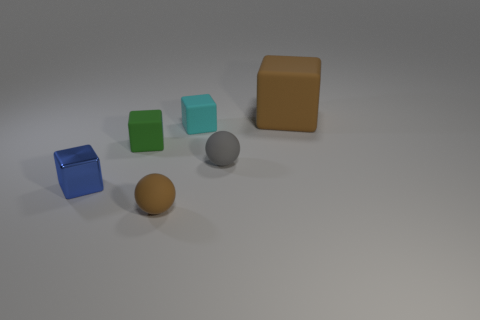Subtract all big brown rubber blocks. How many blocks are left? 3 Subtract 2 cubes. How many cubes are left? 2 Add 3 brown rubber balls. How many objects exist? 9 Subtract all brown balls. How many balls are left? 1 Subtract all cubes. How many objects are left? 2 Subtract all green cubes. Subtract all blue cylinders. How many cubes are left? 3 Subtract all green spheres. How many purple blocks are left? 0 Subtract all tiny gray cylinders. Subtract all rubber cubes. How many objects are left? 3 Add 6 rubber spheres. How many rubber spheres are left? 8 Add 1 gray things. How many gray things exist? 2 